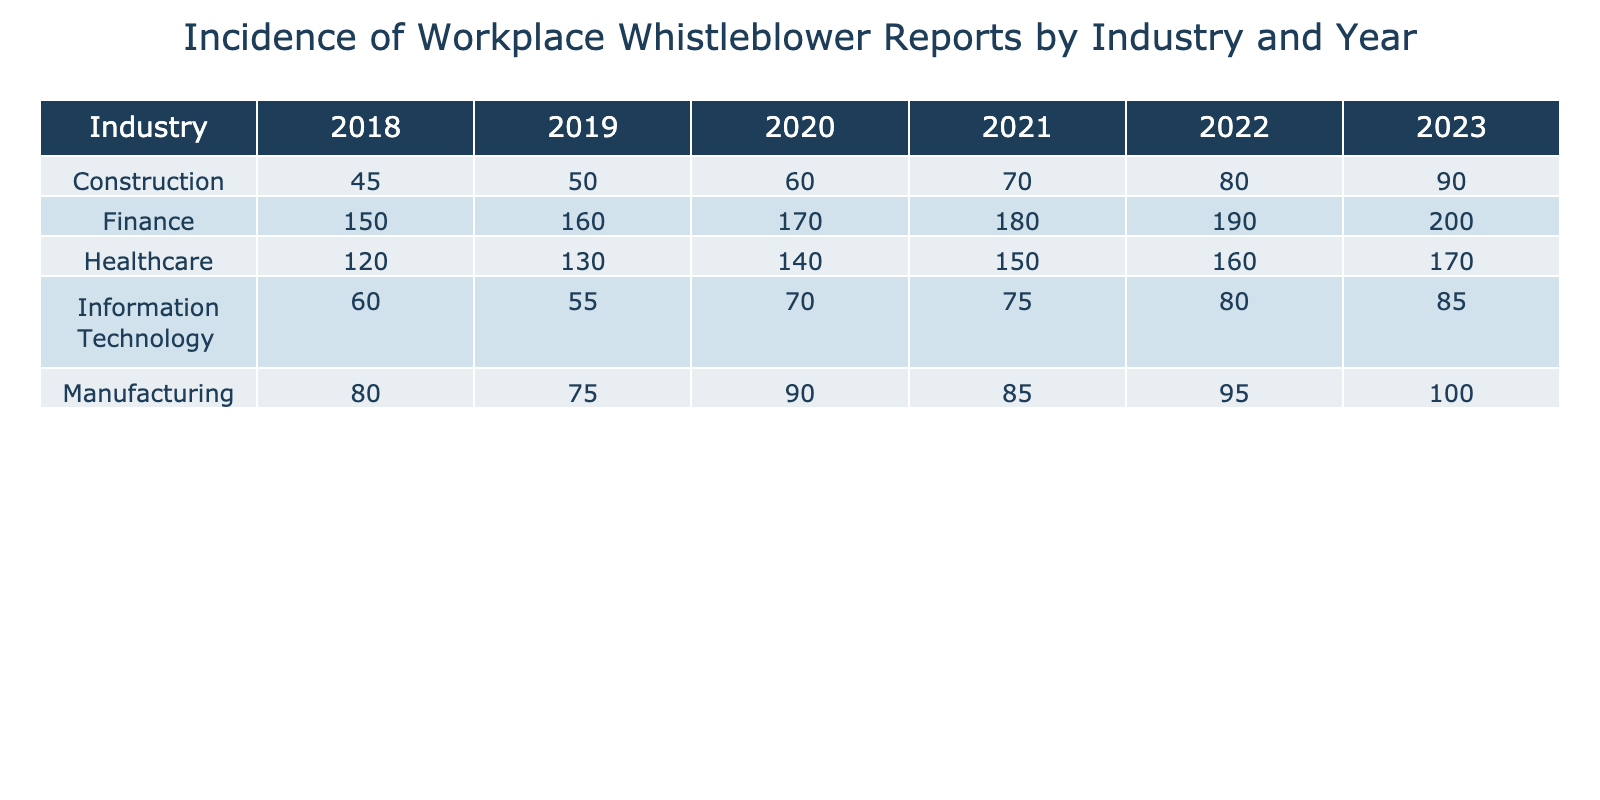What industry had the highest number of whistleblower reports in 2022? In the table, for the year 2022, we can look at the values in the Healthcare, Manufacturing, Finance, Construction, and Information Technology rows. The Finance industry has the highest number of reports at 190.
Answer: Finance How many whistleblower reports did the Construction industry receive in 2020? Referring to the year 2020, the Construction row shows a total of 60 whistleblower reports.
Answer: 60 Which industry experienced an increase in whistleblower reports from 2020 to 2021? By comparing the values for each industry between 2020 and 2021, we find that all industries except Manufacturing and Information Technology experienced an increase. Notably, Healthcare increased from 140 to 150, Finance from 170 to 180, Construction from 60 to 70, and Manufacturing rose slightly to 85.
Answer: Yes What was the total number of whistleblower reports across all industries in 2019? Summing the reports for each industry in 2019 gives us: 130 (Healthcare) + 75 (Manufacturing) + 160 (Finance) + 50 (Construction) + 55 (Information Technology) = 470.
Answer: 470 Which year showed the largest increase in whistleblower reports for the Healthcare industry? To determine this, we will look at the Healthcare values in each year: 120 (2018), 130 (2019), 140 (2020), 150 (2021), 160 (2022), and 170 (2023). The largest year-on-year increase is from 2021 to 2022, where the number increased from 150 to 160, which is an increase of 10 reports.
Answer: 10 What is the difference in the number of whistleblower reports between Finance in 2022 and Manufacturing in 2021? First, we retrieve the number of reports for Finance in 2022, which is 190, and for Manufacturing in 2021, which is 85. We then calculate the difference: 190 - 85 = 105.
Answer: 105 Did the Information Technology industry receive an equal number of reports in 2020 and 2021? Looking at the values within the Information Technology industry for both years, 2020 had 70 reports and 2021 had 75. Therefore, they are not equal.
Answer: No Which industry had the lowest number of whistleblower reports in 2018? From the 2018 values, we compare: Healthcare (120), Manufacturing (80), Finance (150), Construction (45), and Information Technology (60). Construction had the lowest with 45.
Answer: Construction 